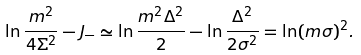<formula> <loc_0><loc_0><loc_500><loc_500>\ln \frac { m ^ { 2 } } { 4 \Sigma ^ { 2 } } - J _ { - } \simeq \ln \frac { m ^ { 2 } \Delta ^ { 2 } } { 2 } - \ln \frac { \Delta ^ { 2 } } { 2 \sigma ^ { 2 } } = \ln ( m \sigma ) ^ { 2 } .</formula> 